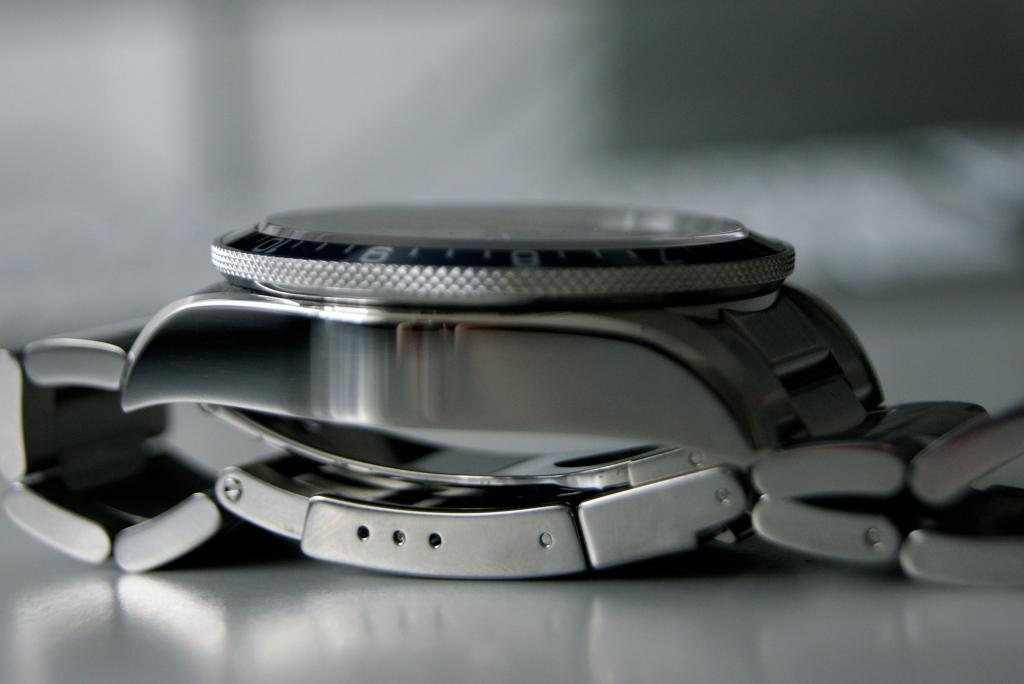What object is the main focus of the image? There is a watch in the image. Can you describe the background of the image? The background of the image is blurred. What type of gate can be seen in the background of the image? There is no gate present in the image; the background is blurred. How many turkeys are visible in the image? There are no turkeys present in the image. 